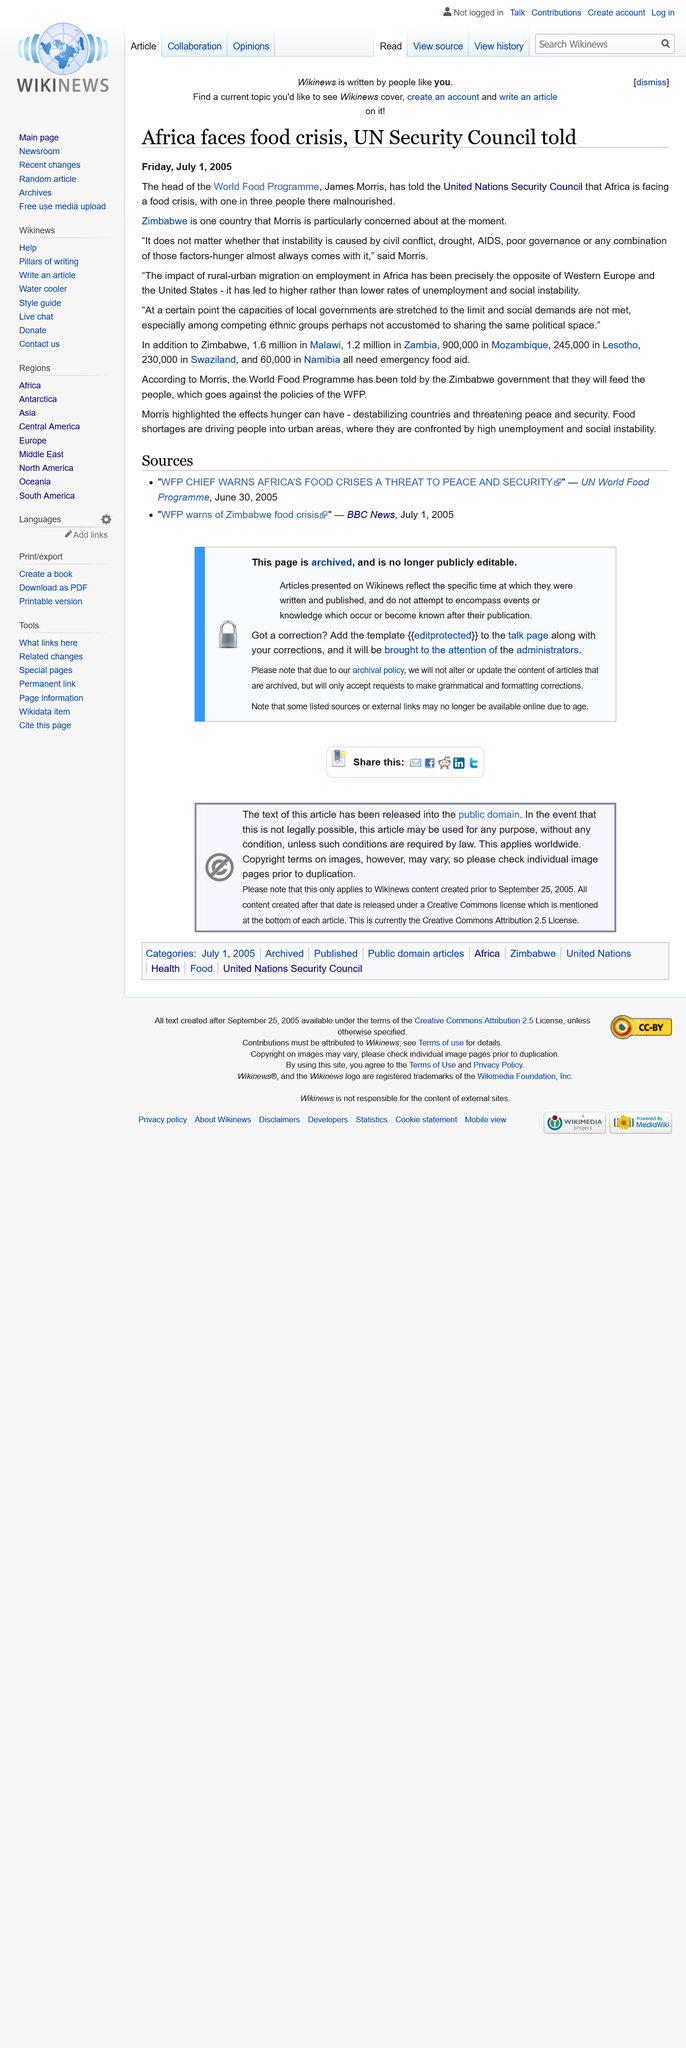Draw attention to some important aspects in this diagram. According to statistics, one in every three people in Africa is malnourished, making it the region with the highest prevalence of malnutrition in the world. James Morris is the head of the World Food Programme, and as such, he holds a high position of authority within the organization. The head of the World Food Programme is deeply concerned about the situation in Zimbabwe. 